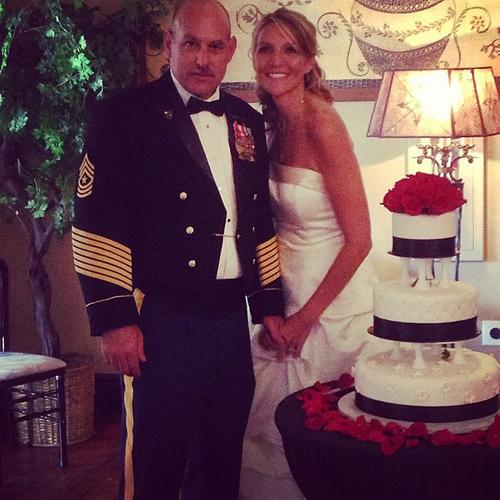Mention the distinctive feature of the groom's attire in the picture. The groom is wearing a military uniform with small silver buttons and a black bow tie. State the color and general appearance of the depicted wedding cake. The wedding cake is a three-tiered, white and navy cake with black trimming and red flowers on top. How would you describe the flooring in the image? The flooring appears to be dark wooden board. Compare the given subjects in the image: woman and the cake. The woman is wearing a strapless wedding dress, and the cake is a three-tiered black and white wedding cake with roses on top. Comment on the lighting fixture visible in the background of the image. There is a brightly lit decorative lamp with a light brown shade, mounted on the wall. Identify the two objects closest to the basket with fake tree in the picture. A black-legged chair and a table with red rose petals on the black tablecloth. Briefly describe the scene in the image related to the couple. The bride and groom are holding hands, with the bride wearing a strapless wedding dress and the groom wearing a military uniform. Which objects in the image involve hands? The bride and groom are holding hands, and there is another image of two hands being held. List the three main items on the table in the image. The red rose petals, a white and black wedding cake, and a basket containing a fake tree. What is the main object on the table in the picture? A three-tiered white and black wedding cake with red rose petals around it. 